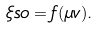Convert formula to latex. <formula><loc_0><loc_0><loc_500><loc_500>\xi s o = f ( \mu v ) .</formula> 